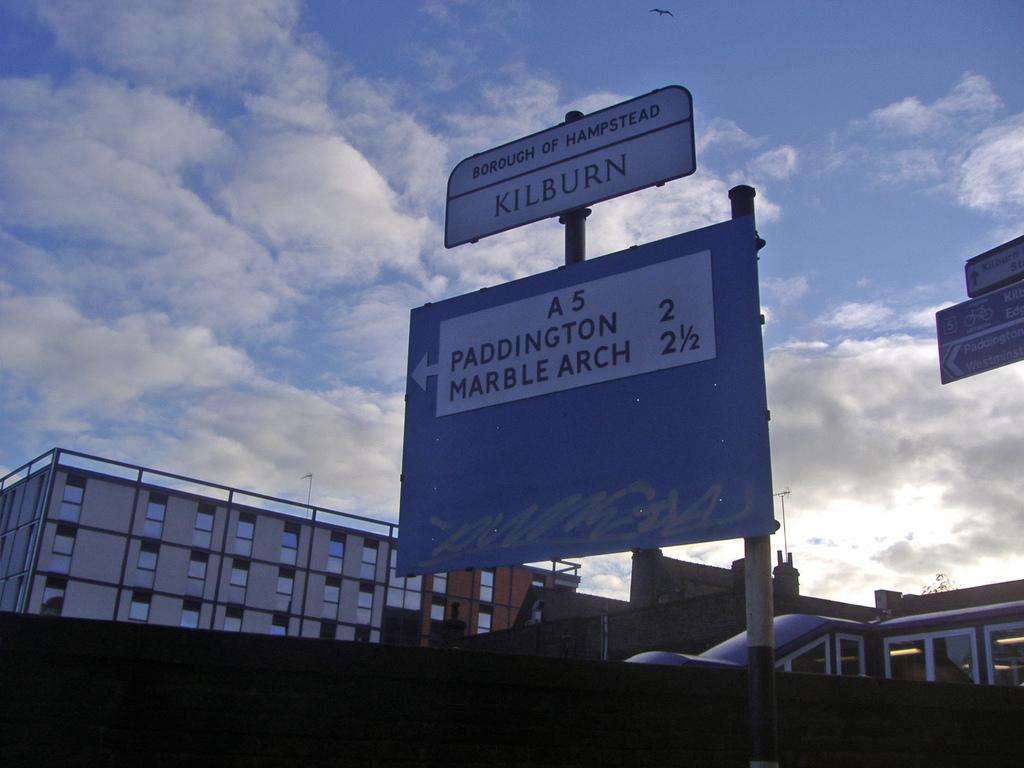What type of structures can be seen in the image? There are buildings in the image. What objects are present in addition to the buildings? There are boards and a vehicle in the image. Is there a volcano erupting in the image? No, there is no volcano present in the image. What type of material is the vehicle made of in the image? The provided facts do not specify the material of the vehicle, so it cannot be determined from the image. 